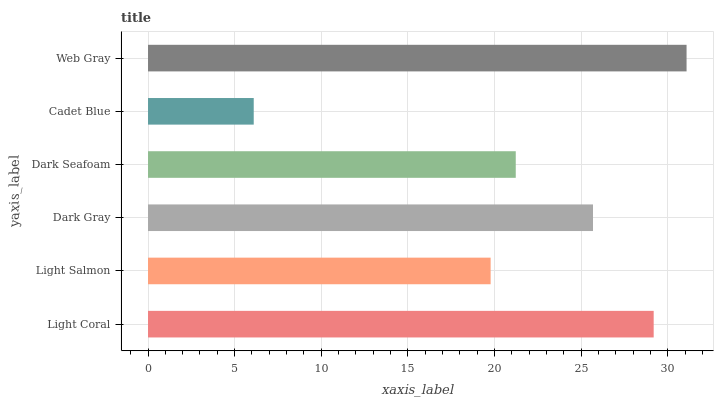Is Cadet Blue the minimum?
Answer yes or no. Yes. Is Web Gray the maximum?
Answer yes or no. Yes. Is Light Salmon the minimum?
Answer yes or no. No. Is Light Salmon the maximum?
Answer yes or no. No. Is Light Coral greater than Light Salmon?
Answer yes or no. Yes. Is Light Salmon less than Light Coral?
Answer yes or no. Yes. Is Light Salmon greater than Light Coral?
Answer yes or no. No. Is Light Coral less than Light Salmon?
Answer yes or no. No. Is Dark Gray the high median?
Answer yes or no. Yes. Is Dark Seafoam the low median?
Answer yes or no. Yes. Is Cadet Blue the high median?
Answer yes or no. No. Is Web Gray the low median?
Answer yes or no. No. 